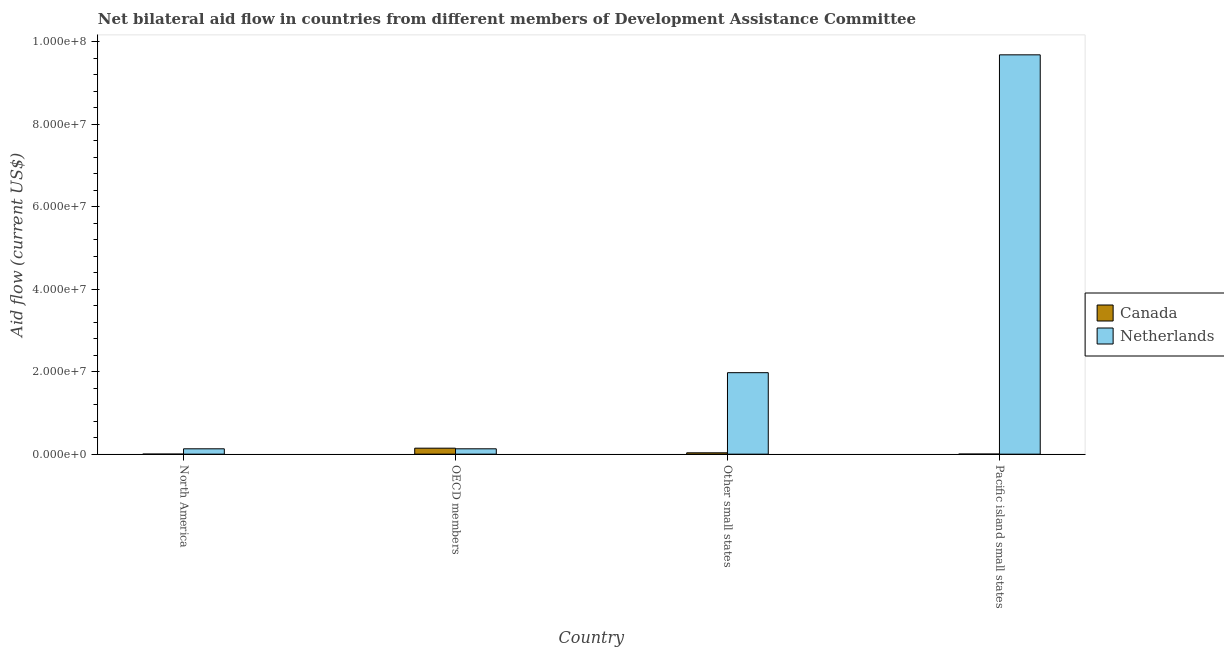How many different coloured bars are there?
Your answer should be very brief. 2. What is the label of the 2nd group of bars from the left?
Give a very brief answer. OECD members. What is the amount of aid given by canada in North America?
Your answer should be compact. 10000. Across all countries, what is the maximum amount of aid given by canada?
Your answer should be very brief. 1.45e+06. Across all countries, what is the minimum amount of aid given by canada?
Give a very brief answer. 10000. In which country was the amount of aid given by netherlands maximum?
Offer a terse response. Pacific island small states. In which country was the amount of aid given by netherlands minimum?
Ensure brevity in your answer.  North America. What is the total amount of aid given by netherlands in the graph?
Ensure brevity in your answer.  1.19e+08. What is the difference between the amount of aid given by netherlands in North America and that in Pacific island small states?
Ensure brevity in your answer.  -9.55e+07. What is the difference between the amount of aid given by netherlands in North America and the amount of aid given by canada in Other small states?
Offer a very short reply. 9.70e+05. What is the average amount of aid given by canada per country?
Keep it short and to the point. 4.52e+05. What is the difference between the amount of aid given by canada and amount of aid given by netherlands in Pacific island small states?
Provide a short and direct response. -9.68e+07. In how many countries, is the amount of aid given by canada greater than 4000000 US$?
Provide a short and direct response. 0. What is the ratio of the amount of aid given by canada in Other small states to that in Pacific island small states?
Offer a very short reply. 16.5. Is the amount of aid given by canada in North America less than that in OECD members?
Provide a short and direct response. Yes. What is the difference between the highest and the second highest amount of aid given by canada?
Offer a very short reply. 1.12e+06. What is the difference between the highest and the lowest amount of aid given by canada?
Make the answer very short. 1.44e+06. In how many countries, is the amount of aid given by netherlands greater than the average amount of aid given by netherlands taken over all countries?
Your response must be concise. 1. Is the sum of the amount of aid given by netherlands in North America and Other small states greater than the maximum amount of aid given by canada across all countries?
Give a very brief answer. Yes. What does the 2nd bar from the left in North America represents?
Your response must be concise. Netherlands. How many bars are there?
Provide a short and direct response. 8. Are all the bars in the graph horizontal?
Ensure brevity in your answer.  No. How many countries are there in the graph?
Your answer should be very brief. 4. What is the difference between two consecutive major ticks on the Y-axis?
Keep it short and to the point. 2.00e+07. Are the values on the major ticks of Y-axis written in scientific E-notation?
Give a very brief answer. Yes. How are the legend labels stacked?
Keep it short and to the point. Vertical. What is the title of the graph?
Keep it short and to the point. Net bilateral aid flow in countries from different members of Development Assistance Committee. Does "Urban Population" appear as one of the legend labels in the graph?
Make the answer very short. No. What is the label or title of the X-axis?
Make the answer very short. Country. What is the Aid flow (current US$) of Canada in North America?
Your answer should be very brief. 10000. What is the Aid flow (current US$) of Netherlands in North America?
Offer a very short reply. 1.30e+06. What is the Aid flow (current US$) of Canada in OECD members?
Keep it short and to the point. 1.45e+06. What is the Aid flow (current US$) of Netherlands in OECD members?
Keep it short and to the point. 1.30e+06. What is the Aid flow (current US$) in Canada in Other small states?
Your answer should be very brief. 3.30e+05. What is the Aid flow (current US$) in Netherlands in Other small states?
Your answer should be compact. 1.98e+07. What is the Aid flow (current US$) in Canada in Pacific island small states?
Your response must be concise. 2.00e+04. What is the Aid flow (current US$) in Netherlands in Pacific island small states?
Ensure brevity in your answer.  9.68e+07. Across all countries, what is the maximum Aid flow (current US$) of Canada?
Your answer should be very brief. 1.45e+06. Across all countries, what is the maximum Aid flow (current US$) in Netherlands?
Offer a terse response. 9.68e+07. Across all countries, what is the minimum Aid flow (current US$) in Canada?
Ensure brevity in your answer.  10000. Across all countries, what is the minimum Aid flow (current US$) in Netherlands?
Provide a succinct answer. 1.30e+06. What is the total Aid flow (current US$) in Canada in the graph?
Give a very brief answer. 1.81e+06. What is the total Aid flow (current US$) in Netherlands in the graph?
Your response must be concise. 1.19e+08. What is the difference between the Aid flow (current US$) of Canada in North America and that in OECD members?
Offer a very short reply. -1.44e+06. What is the difference between the Aid flow (current US$) of Canada in North America and that in Other small states?
Offer a very short reply. -3.20e+05. What is the difference between the Aid flow (current US$) in Netherlands in North America and that in Other small states?
Your response must be concise. -1.85e+07. What is the difference between the Aid flow (current US$) of Netherlands in North America and that in Pacific island small states?
Offer a terse response. -9.55e+07. What is the difference between the Aid flow (current US$) in Canada in OECD members and that in Other small states?
Provide a short and direct response. 1.12e+06. What is the difference between the Aid flow (current US$) of Netherlands in OECD members and that in Other small states?
Your response must be concise. -1.85e+07. What is the difference between the Aid flow (current US$) of Canada in OECD members and that in Pacific island small states?
Offer a terse response. 1.43e+06. What is the difference between the Aid flow (current US$) of Netherlands in OECD members and that in Pacific island small states?
Your answer should be compact. -9.55e+07. What is the difference between the Aid flow (current US$) of Netherlands in Other small states and that in Pacific island small states?
Your response must be concise. -7.71e+07. What is the difference between the Aid flow (current US$) of Canada in North America and the Aid flow (current US$) of Netherlands in OECD members?
Offer a very short reply. -1.29e+06. What is the difference between the Aid flow (current US$) in Canada in North America and the Aid flow (current US$) in Netherlands in Other small states?
Offer a terse response. -1.98e+07. What is the difference between the Aid flow (current US$) of Canada in North America and the Aid flow (current US$) of Netherlands in Pacific island small states?
Your answer should be very brief. -9.68e+07. What is the difference between the Aid flow (current US$) in Canada in OECD members and the Aid flow (current US$) in Netherlands in Other small states?
Make the answer very short. -1.83e+07. What is the difference between the Aid flow (current US$) of Canada in OECD members and the Aid flow (current US$) of Netherlands in Pacific island small states?
Give a very brief answer. -9.54e+07. What is the difference between the Aid flow (current US$) in Canada in Other small states and the Aid flow (current US$) in Netherlands in Pacific island small states?
Give a very brief answer. -9.65e+07. What is the average Aid flow (current US$) of Canada per country?
Your response must be concise. 4.52e+05. What is the average Aid flow (current US$) of Netherlands per country?
Give a very brief answer. 2.98e+07. What is the difference between the Aid flow (current US$) in Canada and Aid flow (current US$) in Netherlands in North America?
Offer a very short reply. -1.29e+06. What is the difference between the Aid flow (current US$) in Canada and Aid flow (current US$) in Netherlands in Other small states?
Your response must be concise. -1.94e+07. What is the difference between the Aid flow (current US$) in Canada and Aid flow (current US$) in Netherlands in Pacific island small states?
Your response must be concise. -9.68e+07. What is the ratio of the Aid flow (current US$) in Canada in North America to that in OECD members?
Provide a short and direct response. 0.01. What is the ratio of the Aid flow (current US$) of Netherlands in North America to that in OECD members?
Your response must be concise. 1. What is the ratio of the Aid flow (current US$) in Canada in North America to that in Other small states?
Offer a very short reply. 0.03. What is the ratio of the Aid flow (current US$) of Netherlands in North America to that in Other small states?
Offer a terse response. 0.07. What is the ratio of the Aid flow (current US$) of Canada in North America to that in Pacific island small states?
Make the answer very short. 0.5. What is the ratio of the Aid flow (current US$) in Netherlands in North America to that in Pacific island small states?
Your answer should be compact. 0.01. What is the ratio of the Aid flow (current US$) of Canada in OECD members to that in Other small states?
Ensure brevity in your answer.  4.39. What is the ratio of the Aid flow (current US$) of Netherlands in OECD members to that in Other small states?
Give a very brief answer. 0.07. What is the ratio of the Aid flow (current US$) in Canada in OECD members to that in Pacific island small states?
Ensure brevity in your answer.  72.5. What is the ratio of the Aid flow (current US$) in Netherlands in OECD members to that in Pacific island small states?
Provide a short and direct response. 0.01. What is the ratio of the Aid flow (current US$) in Canada in Other small states to that in Pacific island small states?
Offer a terse response. 16.5. What is the ratio of the Aid flow (current US$) in Netherlands in Other small states to that in Pacific island small states?
Your answer should be very brief. 0.2. What is the difference between the highest and the second highest Aid flow (current US$) in Canada?
Ensure brevity in your answer.  1.12e+06. What is the difference between the highest and the second highest Aid flow (current US$) in Netherlands?
Offer a very short reply. 7.71e+07. What is the difference between the highest and the lowest Aid flow (current US$) of Canada?
Keep it short and to the point. 1.44e+06. What is the difference between the highest and the lowest Aid flow (current US$) in Netherlands?
Offer a terse response. 9.55e+07. 